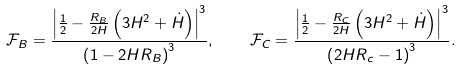<formula> <loc_0><loc_0><loc_500><loc_500>\mathcal { F } _ { B } = \frac { \left | \frac { 1 } { 2 } - \frac { R _ { B } } { 2 H } \left ( 3 H ^ { 2 } + \dot { H } \right ) \right | ^ { 3 } } { \left ( 1 - 2 H R _ { B } \right ) ^ { 3 } } , \quad \mathcal { F } _ { C } = \frac { \left | \frac { 1 } { 2 } - \frac { R _ { C } } { 2 H } \left ( 3 H ^ { 2 } + \dot { H } \right ) \right | ^ { 3 } } { \left ( 2 H R _ { c } - 1 \right ) ^ { 3 } } .</formula> 